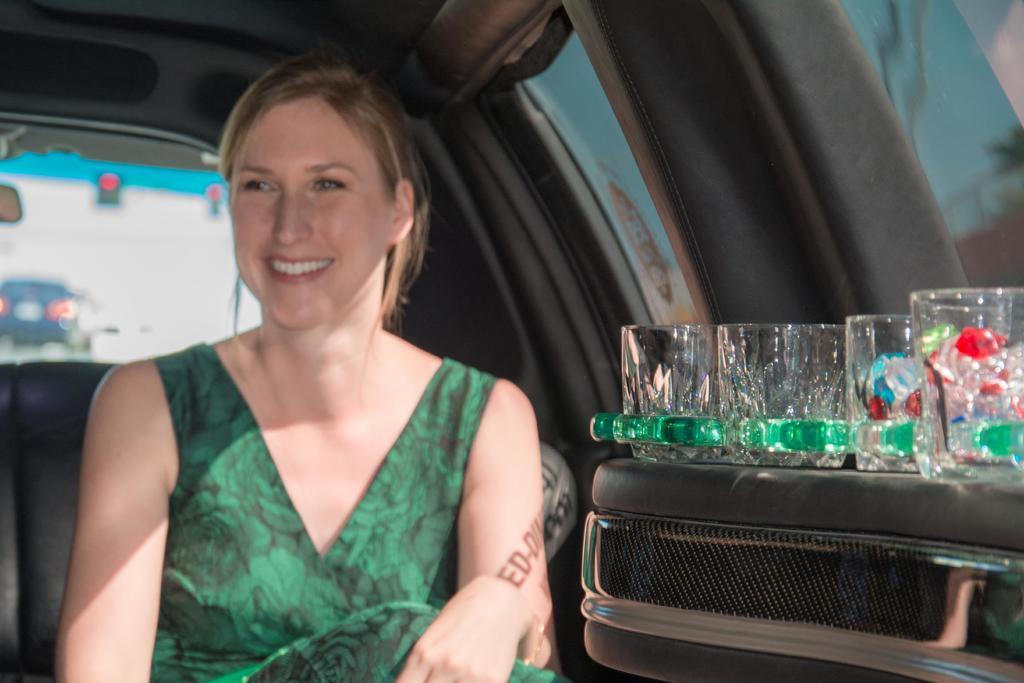How would you summarize this image in a sentence or two? A picture inside of a car. This person is sitting inside a car. On this suitcase there are glasses. Outside of this window we can able to see vehicle. c 